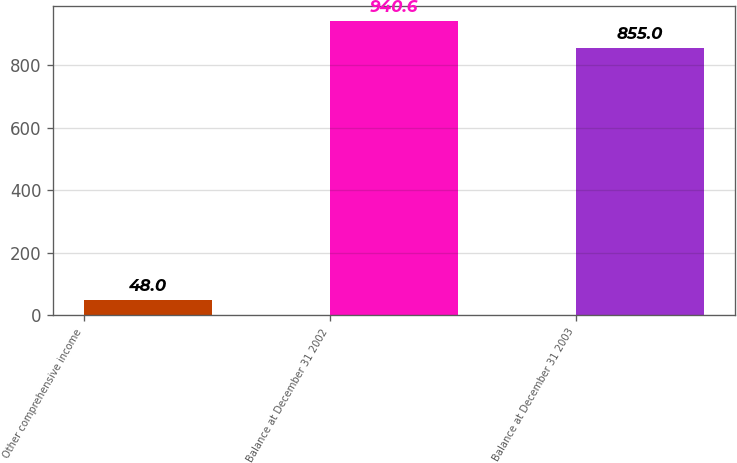Convert chart. <chart><loc_0><loc_0><loc_500><loc_500><bar_chart><fcel>Other comprehensive income<fcel>Balance at December 31 2002<fcel>Balance at December 31 2003<nl><fcel>48<fcel>940.6<fcel>855<nl></chart> 